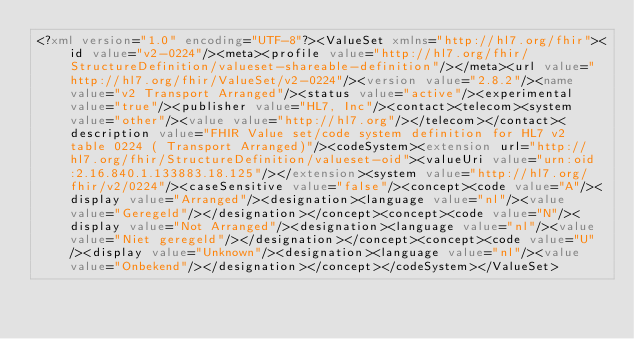Convert code to text. <code><loc_0><loc_0><loc_500><loc_500><_XML_><?xml version="1.0" encoding="UTF-8"?><ValueSet xmlns="http://hl7.org/fhir"><id value="v2-0224"/><meta><profile value="http://hl7.org/fhir/StructureDefinition/valueset-shareable-definition"/></meta><url value="http://hl7.org/fhir/ValueSet/v2-0224"/><version value="2.8.2"/><name value="v2 Transport Arranged"/><status value="active"/><experimental value="true"/><publisher value="HL7, Inc"/><contact><telecom><system value="other"/><value value="http://hl7.org"/></telecom></contact><description value="FHIR Value set/code system definition for HL7 v2 table 0224 ( Transport Arranged)"/><codeSystem><extension url="http://hl7.org/fhir/StructureDefinition/valueset-oid"><valueUri value="urn:oid:2.16.840.1.133883.18.125"/></extension><system value="http://hl7.org/fhir/v2/0224"/><caseSensitive value="false"/><concept><code value="A"/><display value="Arranged"/><designation><language value="nl"/><value value="Geregeld"/></designation></concept><concept><code value="N"/><display value="Not Arranged"/><designation><language value="nl"/><value value="Niet geregeld"/></designation></concept><concept><code value="U"/><display value="Unknown"/><designation><language value="nl"/><value value="Onbekend"/></designation></concept></codeSystem></ValueSet></code> 